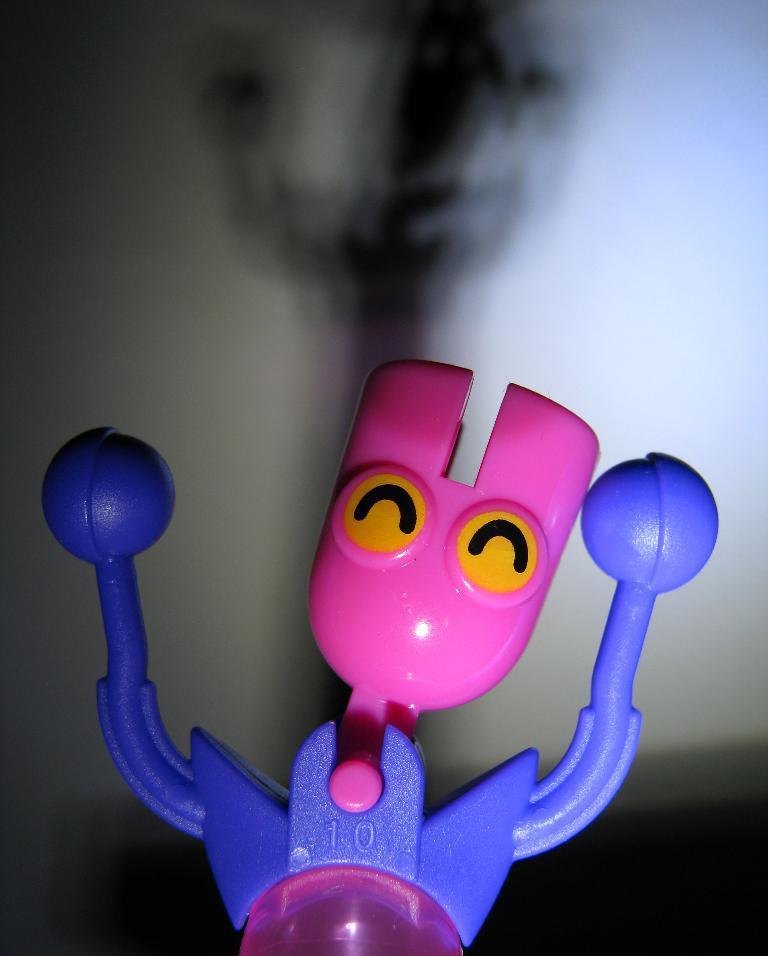In one or two sentences, can you explain what this image depicts? In this image we can see a toy. On the backside we can see a wall. 